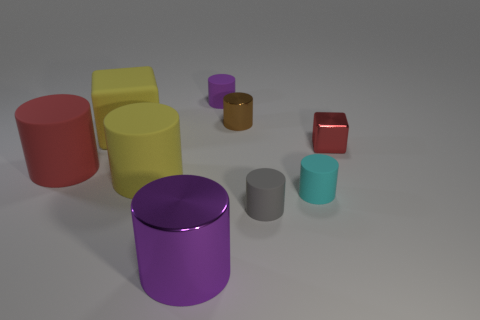Subtract all cyan cylinders. How many cylinders are left? 6 Subtract all brown cylinders. How many cylinders are left? 6 Subtract all cyan cylinders. Subtract all yellow blocks. How many cylinders are left? 6 Add 1 purple shiny things. How many objects exist? 10 Subtract all cylinders. How many objects are left? 2 Subtract 0 green blocks. How many objects are left? 9 Subtract all large yellow things. Subtract all cylinders. How many objects are left? 0 Add 5 yellow cylinders. How many yellow cylinders are left? 6 Add 6 big rubber cylinders. How many big rubber cylinders exist? 8 